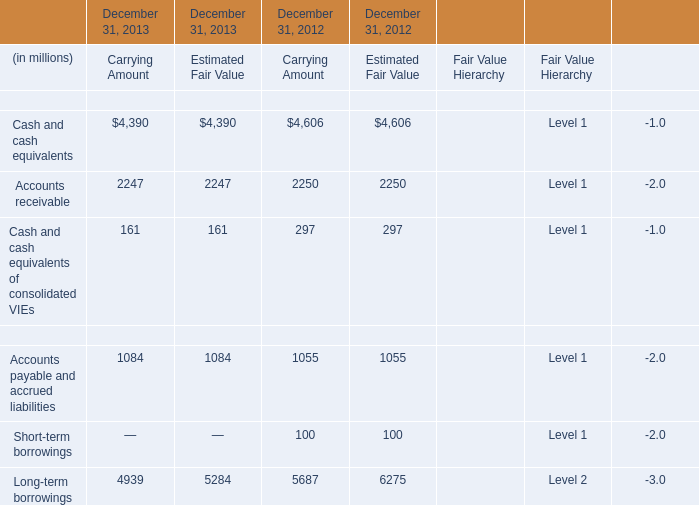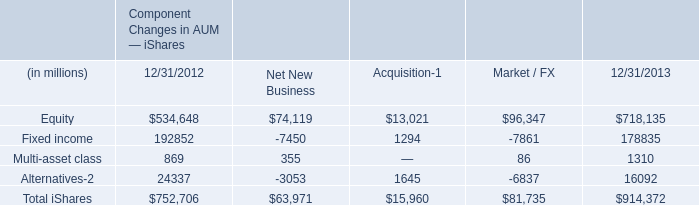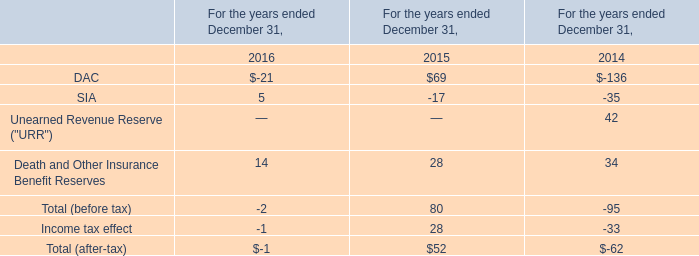What is the average amount of Fixed income of Component Changes in AUM — iShares 12/31/2013, and Cash and cash equivalents of December 31, 2013 Carrying Amount ? 
Computations: ((178835.0 + 4390.0) / 2)
Answer: 91612.5. 